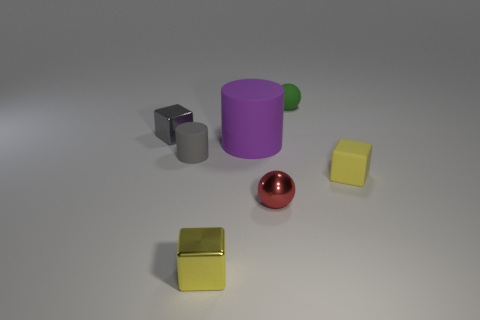Subtract all rubber blocks. How many blocks are left? 2 Add 2 yellow shiny cubes. How many objects exist? 9 Subtract all cubes. How many objects are left? 4 Subtract all green metal cylinders. Subtract all big cylinders. How many objects are left? 6 Add 5 big purple matte things. How many big purple matte things are left? 6 Add 4 big blue metallic balls. How many big blue metallic balls exist? 4 Subtract all green balls. How many balls are left? 1 Subtract 1 green balls. How many objects are left? 6 Subtract 1 cubes. How many cubes are left? 2 Subtract all cyan balls. Subtract all red cylinders. How many balls are left? 2 